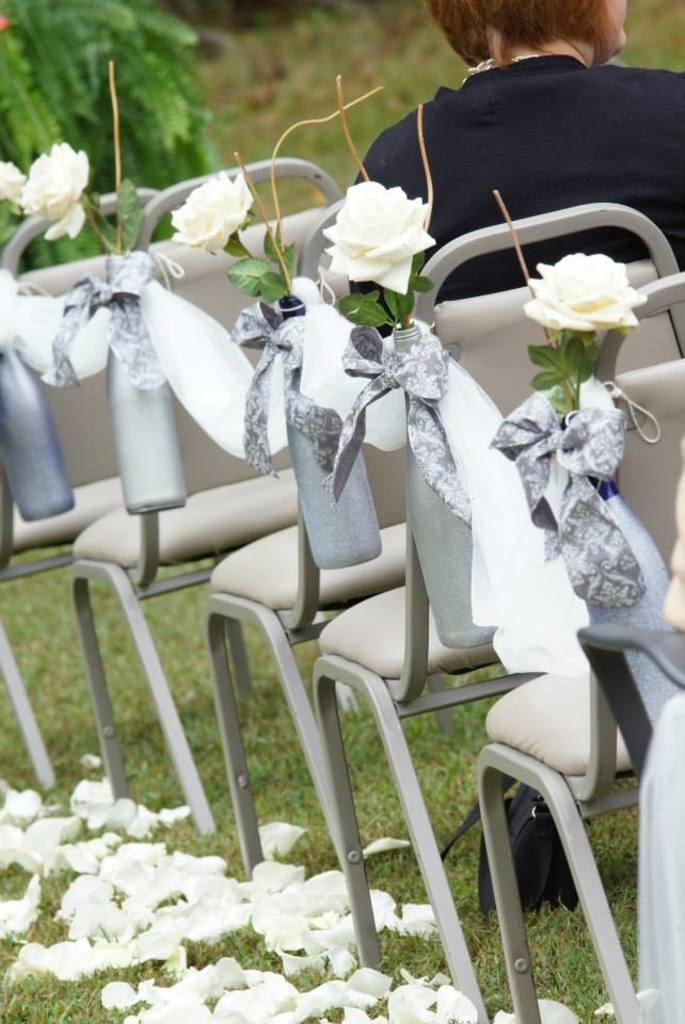What type of furniture can be seen in the image? There are chairs in the image. What decorative items are present in the image? There are ribbons and flowers in the image. What is the person in the image doing? A person is sitting on a chair. What can be seen in the distance in the image? There is a plant in the distance. Where is the cup located in the image? There is no cup present in the image. What type of alley can be seen in the image? There is no alley present in the image. 